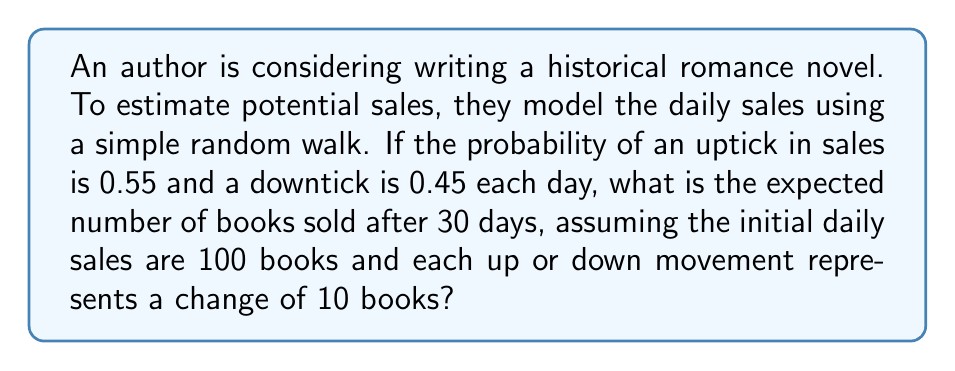Show me your answer to this math problem. Let's approach this step-by-step:

1) This is a biased random walk problem. The expected change in sales each day is:

   $E[\text{daily change}] = 0.55 \cdot 10 + 0.45 \cdot (-10) = 5.5 - 4.5 = 1$ book

2) Over 30 days, the expected total change is:

   $E[\text{total change}] = 30 \cdot 1 = 30$ books

3) The initial sales are 100 books per day. After 30 days, the expected sales would be:

   $E[\text{sales after 30 days}] = 100 + 30 = 130$ books

4) To verify this mathematically:

   Let $X_t$ be the number of books sold on day $t$.
   $X_0 = 100$
   $E[X_t | X_{t-1}] = X_{t-1} + 1$

   By the law of iterated expectations:
   
   $$\begin{align}
   E[X_{30}] &= E[E[X_{30} | X_{29}]] \\
              &= E[X_{29} + 1] \\
              &= E[X_{29}] + 1 \\
              &= E[X_{28}] + 1 + 1 \\
              &= ... \\
              &= X_0 + 30 \cdot 1 \\
              &= 100 + 30 \\
              &= 130
   \end{align}$$

Thus, after 30 days, the expected number of books sold is 130.
Answer: 130 books 